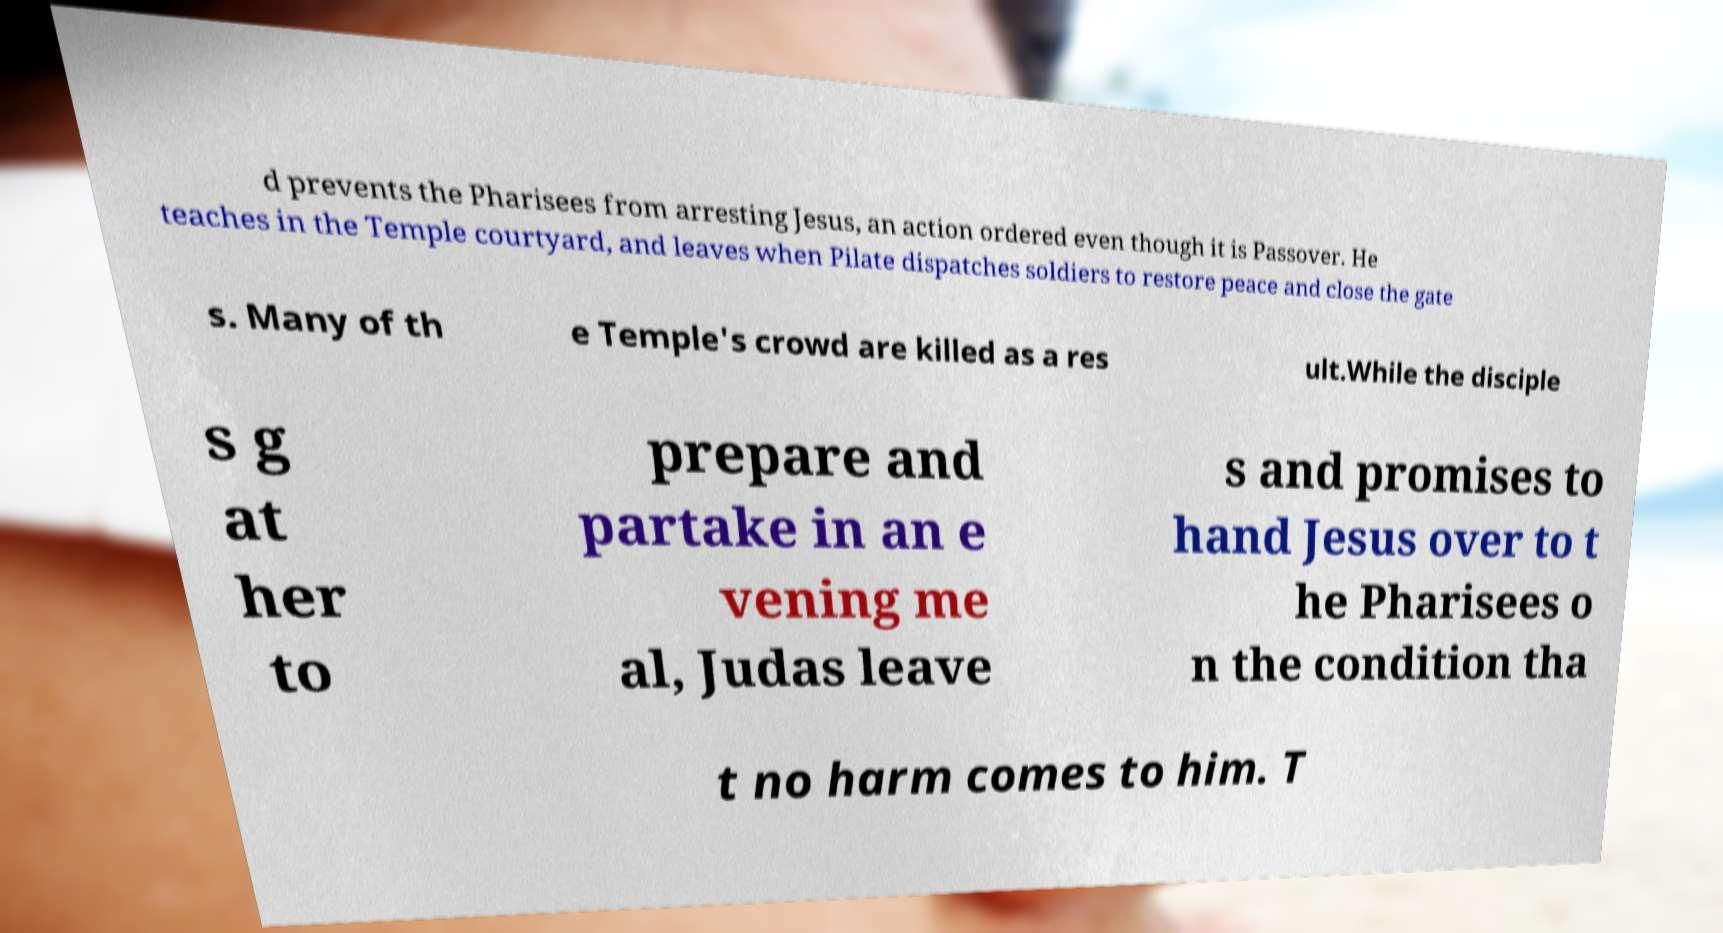Could you assist in decoding the text presented in this image and type it out clearly? d prevents the Pharisees from arresting Jesus, an action ordered even though it is Passover. He teaches in the Temple courtyard, and leaves when Pilate dispatches soldiers to restore peace and close the gate s. Many of th e Temple's crowd are killed as a res ult.While the disciple s g at her to prepare and partake in an e vening me al, Judas leave s and promises to hand Jesus over to t he Pharisees o n the condition tha t no harm comes to him. T 